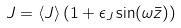<formula> <loc_0><loc_0><loc_500><loc_500>J = \langle J \rangle \left ( 1 + \epsilon _ { J } \sin ( \omega \bar { z } ) \right )</formula> 